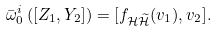Convert formula to latex. <formula><loc_0><loc_0><loc_500><loc_500>\bar { \omega } _ { 0 } ^ { i } \left ( [ Z _ { 1 } , Y _ { 2 } ] \right ) = [ f _ { \mathcal { H } \widetilde { \mathcal { H } } } ( v _ { 1 } ) , v _ { 2 } ] .</formula> 